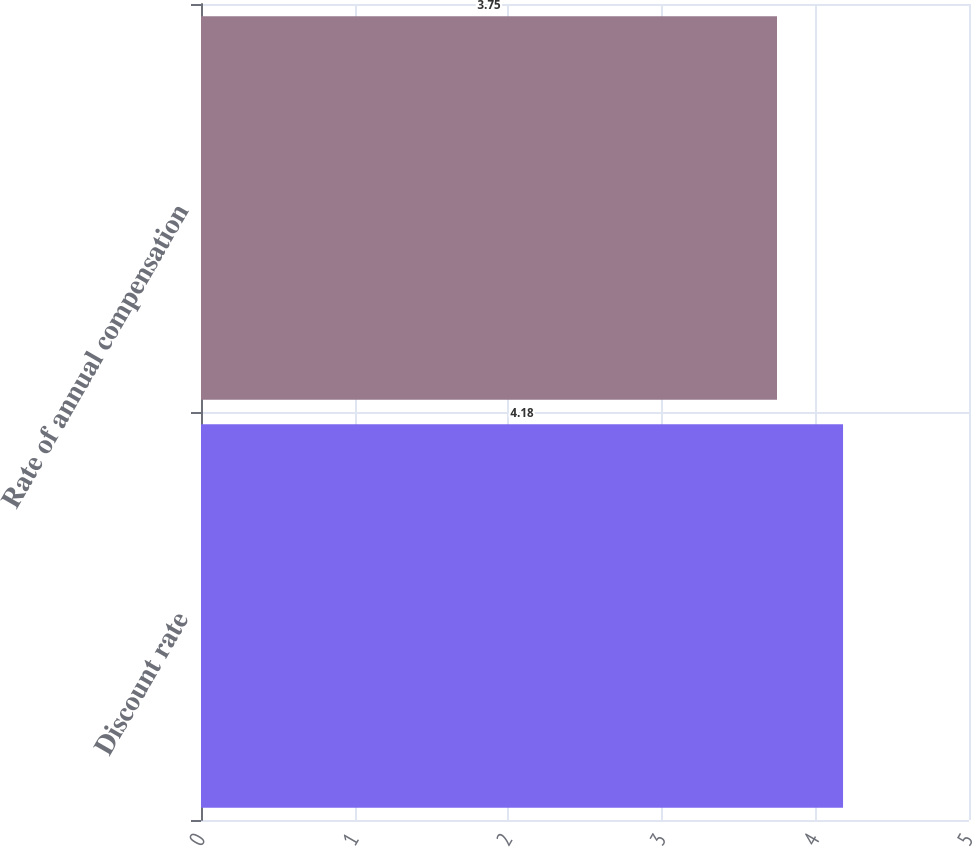Convert chart. <chart><loc_0><loc_0><loc_500><loc_500><bar_chart><fcel>Discount rate<fcel>Rate of annual compensation<nl><fcel>4.18<fcel>3.75<nl></chart> 